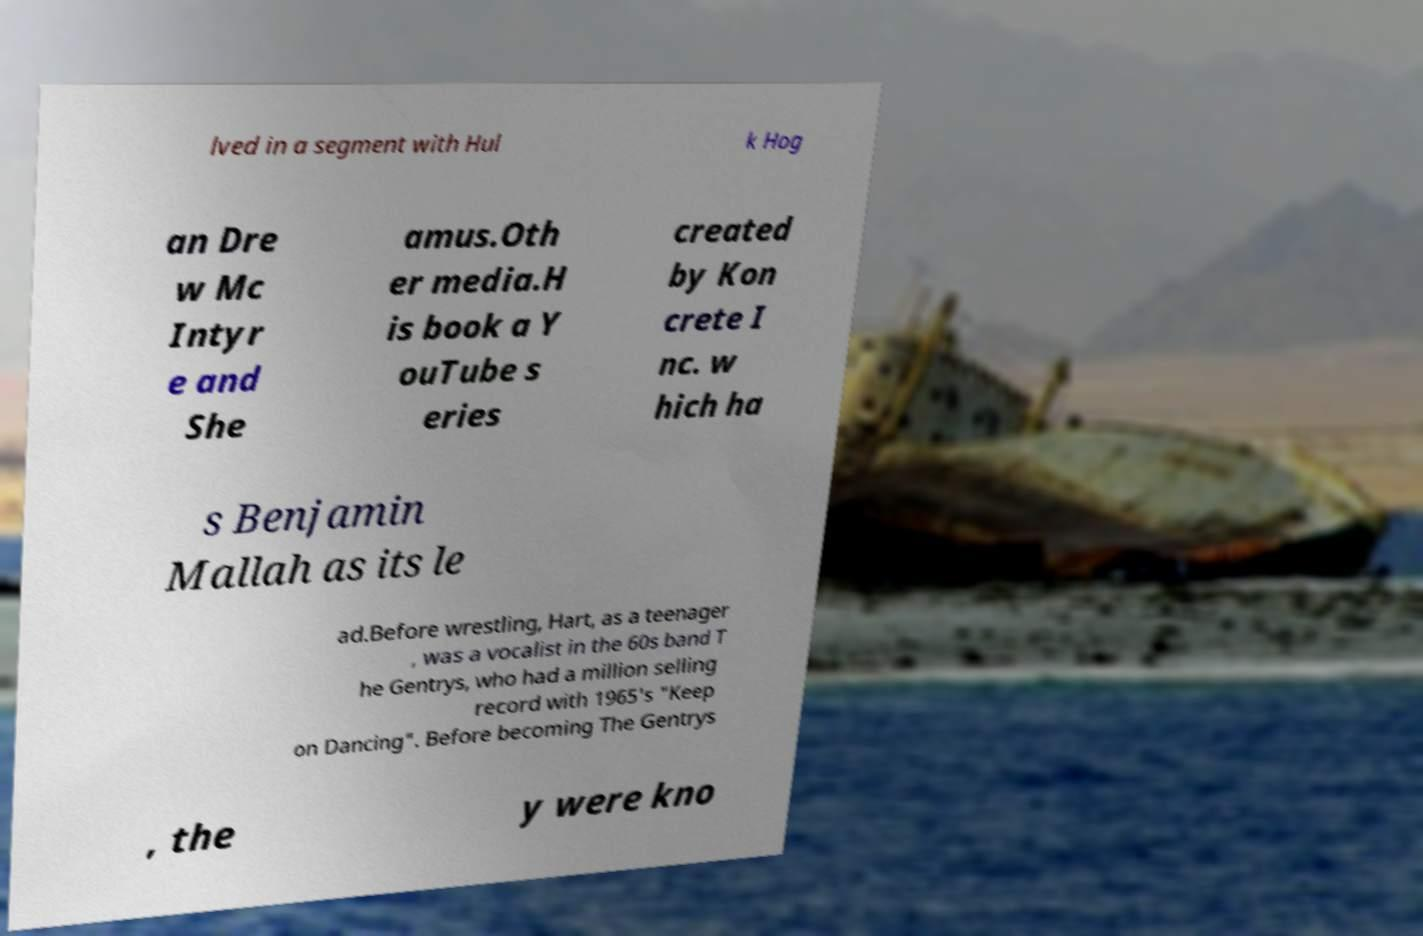I need the written content from this picture converted into text. Can you do that? lved in a segment with Hul k Hog an Dre w Mc Intyr e and She amus.Oth er media.H is book a Y ouTube s eries created by Kon crete I nc. w hich ha s Benjamin Mallah as its le ad.Before wrestling, Hart, as a teenager , was a vocalist in the 60s band T he Gentrys, who had a million selling record with 1965's "Keep on Dancing". Before becoming The Gentrys , the y were kno 